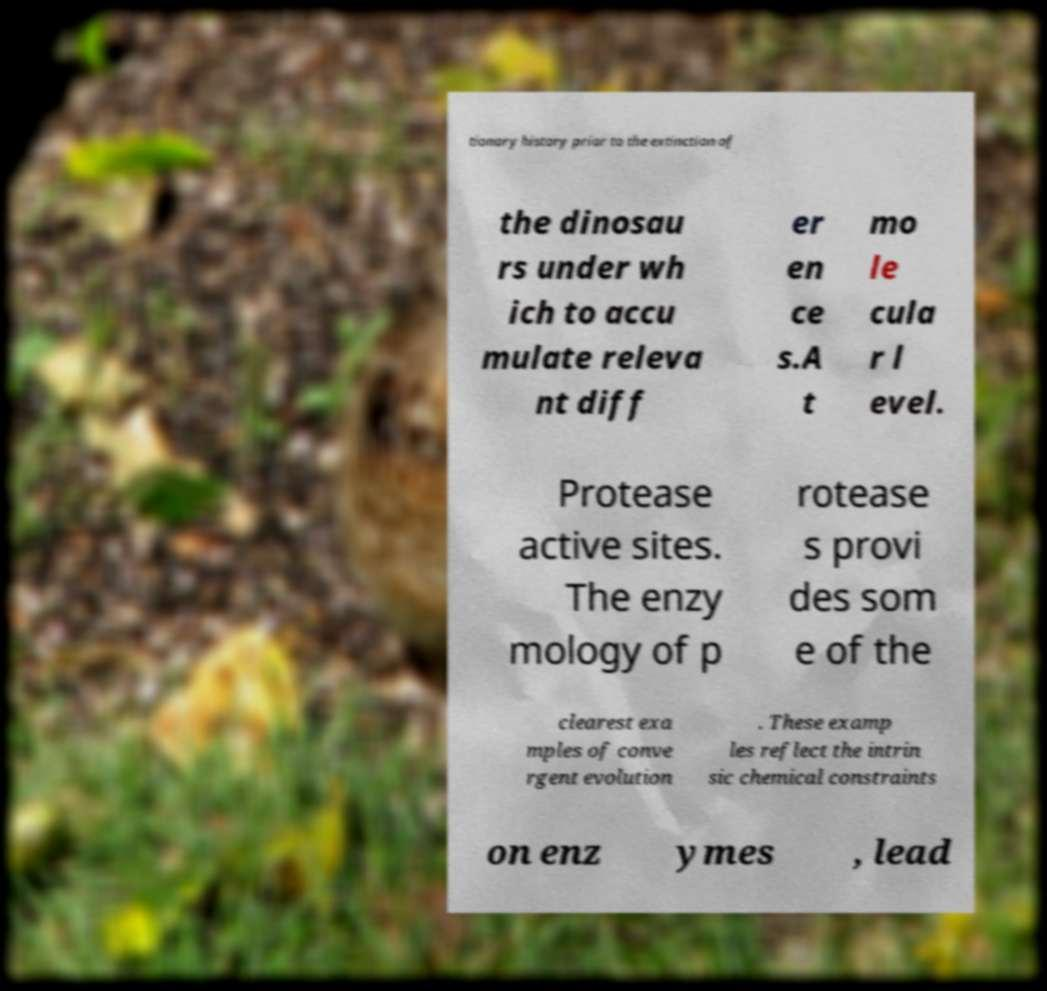There's text embedded in this image that I need extracted. Can you transcribe it verbatim? tionary history prior to the extinction of the dinosau rs under wh ich to accu mulate releva nt diff er en ce s.A t mo le cula r l evel. Protease active sites. The enzy mology of p rotease s provi des som e of the clearest exa mples of conve rgent evolution . These examp les reflect the intrin sic chemical constraints on enz ymes , lead 